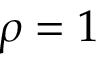<formula> <loc_0><loc_0><loc_500><loc_500>\rho = 1</formula> 